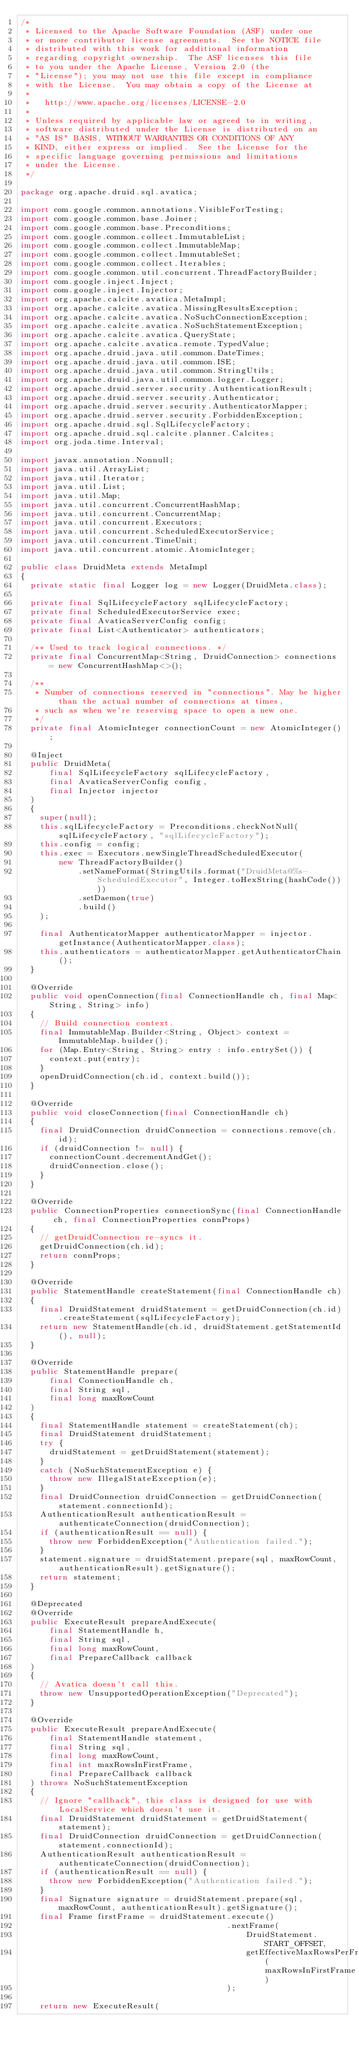Convert code to text. <code><loc_0><loc_0><loc_500><loc_500><_Java_>/*
 * Licensed to the Apache Software Foundation (ASF) under one
 * or more contributor license agreements.  See the NOTICE file
 * distributed with this work for additional information
 * regarding copyright ownership.  The ASF licenses this file
 * to you under the Apache License, Version 2.0 (the
 * "License"); you may not use this file except in compliance
 * with the License.  You may obtain a copy of the License at
 *
 *   http://www.apache.org/licenses/LICENSE-2.0
 *
 * Unless required by applicable law or agreed to in writing,
 * software distributed under the License is distributed on an
 * "AS IS" BASIS, WITHOUT WARRANTIES OR CONDITIONS OF ANY
 * KIND, either express or implied.  See the License for the
 * specific language governing permissions and limitations
 * under the License.
 */

package org.apache.druid.sql.avatica;

import com.google.common.annotations.VisibleForTesting;
import com.google.common.base.Joiner;
import com.google.common.base.Preconditions;
import com.google.common.collect.ImmutableList;
import com.google.common.collect.ImmutableMap;
import com.google.common.collect.ImmutableSet;
import com.google.common.collect.Iterables;
import com.google.common.util.concurrent.ThreadFactoryBuilder;
import com.google.inject.Inject;
import com.google.inject.Injector;
import org.apache.calcite.avatica.MetaImpl;
import org.apache.calcite.avatica.MissingResultsException;
import org.apache.calcite.avatica.NoSuchConnectionException;
import org.apache.calcite.avatica.NoSuchStatementException;
import org.apache.calcite.avatica.QueryState;
import org.apache.calcite.avatica.remote.TypedValue;
import org.apache.druid.java.util.common.DateTimes;
import org.apache.druid.java.util.common.ISE;
import org.apache.druid.java.util.common.StringUtils;
import org.apache.druid.java.util.common.logger.Logger;
import org.apache.druid.server.security.AuthenticationResult;
import org.apache.druid.server.security.Authenticator;
import org.apache.druid.server.security.AuthenticatorMapper;
import org.apache.druid.server.security.ForbiddenException;
import org.apache.druid.sql.SqlLifecycleFactory;
import org.apache.druid.sql.calcite.planner.Calcites;
import org.joda.time.Interval;

import javax.annotation.Nonnull;
import java.util.ArrayList;
import java.util.Iterator;
import java.util.List;
import java.util.Map;
import java.util.concurrent.ConcurrentHashMap;
import java.util.concurrent.ConcurrentMap;
import java.util.concurrent.Executors;
import java.util.concurrent.ScheduledExecutorService;
import java.util.concurrent.TimeUnit;
import java.util.concurrent.atomic.AtomicInteger;

public class DruidMeta extends MetaImpl
{
  private static final Logger log = new Logger(DruidMeta.class);

  private final SqlLifecycleFactory sqlLifecycleFactory;
  private final ScheduledExecutorService exec;
  private final AvaticaServerConfig config;
  private final List<Authenticator> authenticators;

  /** Used to track logical connections. */
  private final ConcurrentMap<String, DruidConnection> connections = new ConcurrentHashMap<>();

  /**
   * Number of connections reserved in "connections". May be higher than the actual number of connections at times,
   * such as when we're reserving space to open a new one.
   */
  private final AtomicInteger connectionCount = new AtomicInteger();

  @Inject
  public DruidMeta(
      final SqlLifecycleFactory sqlLifecycleFactory,
      final AvaticaServerConfig config,
      final Injector injector
  )
  {
    super(null);
    this.sqlLifecycleFactory = Preconditions.checkNotNull(sqlLifecycleFactory, "sqlLifecycleFactory");
    this.config = config;
    this.exec = Executors.newSingleThreadScheduledExecutor(
        new ThreadFactoryBuilder()
            .setNameFormat(StringUtils.format("DruidMeta@%s-ScheduledExecutor", Integer.toHexString(hashCode())))
            .setDaemon(true)
            .build()
    );

    final AuthenticatorMapper authenticatorMapper = injector.getInstance(AuthenticatorMapper.class);
    this.authenticators = authenticatorMapper.getAuthenticatorChain();
  }

  @Override
  public void openConnection(final ConnectionHandle ch, final Map<String, String> info)
  {
    // Build connection context.
    final ImmutableMap.Builder<String, Object> context = ImmutableMap.builder();
    for (Map.Entry<String, String> entry : info.entrySet()) {
      context.put(entry);
    }
    openDruidConnection(ch.id, context.build());
  }

  @Override
  public void closeConnection(final ConnectionHandle ch)
  {
    final DruidConnection druidConnection = connections.remove(ch.id);
    if (druidConnection != null) {
      connectionCount.decrementAndGet();
      druidConnection.close();
    }
  }

  @Override
  public ConnectionProperties connectionSync(final ConnectionHandle ch, final ConnectionProperties connProps)
  {
    // getDruidConnection re-syncs it.
    getDruidConnection(ch.id);
    return connProps;
  }

  @Override
  public StatementHandle createStatement(final ConnectionHandle ch)
  {
    final DruidStatement druidStatement = getDruidConnection(ch.id).createStatement(sqlLifecycleFactory);
    return new StatementHandle(ch.id, druidStatement.getStatementId(), null);
  }

  @Override
  public StatementHandle prepare(
      final ConnectionHandle ch,
      final String sql,
      final long maxRowCount
  )
  {
    final StatementHandle statement = createStatement(ch);
    final DruidStatement druidStatement;
    try {
      druidStatement = getDruidStatement(statement);
    }
    catch (NoSuchStatementException e) {
      throw new IllegalStateException(e);
    }
    final DruidConnection druidConnection = getDruidConnection(statement.connectionId);
    AuthenticationResult authenticationResult = authenticateConnection(druidConnection);
    if (authenticationResult == null) {
      throw new ForbiddenException("Authentication failed.");
    }
    statement.signature = druidStatement.prepare(sql, maxRowCount, authenticationResult).getSignature();
    return statement;
  }

  @Deprecated
  @Override
  public ExecuteResult prepareAndExecute(
      final StatementHandle h,
      final String sql,
      final long maxRowCount,
      final PrepareCallback callback
  )
  {
    // Avatica doesn't call this.
    throw new UnsupportedOperationException("Deprecated");
  }

  @Override
  public ExecuteResult prepareAndExecute(
      final StatementHandle statement,
      final String sql,
      final long maxRowCount,
      final int maxRowsInFirstFrame,
      final PrepareCallback callback
  ) throws NoSuchStatementException
  {
    // Ignore "callback", this class is designed for use with LocalService which doesn't use it.
    final DruidStatement druidStatement = getDruidStatement(statement);
    final DruidConnection druidConnection = getDruidConnection(statement.connectionId);
    AuthenticationResult authenticationResult = authenticateConnection(druidConnection);
    if (authenticationResult == null) {
      throw new ForbiddenException("Authentication failed.");
    }
    final Signature signature = druidStatement.prepare(sql, maxRowCount, authenticationResult).getSignature();
    final Frame firstFrame = druidStatement.execute()
                                           .nextFrame(
                                               DruidStatement.START_OFFSET,
                                               getEffectiveMaxRowsPerFrame(maxRowsInFirstFrame)
                                           );

    return new ExecuteResult(</code> 